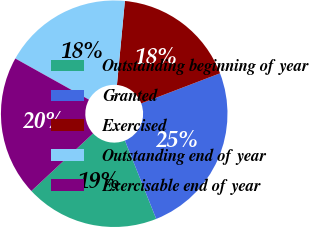Convert chart to OTSL. <chart><loc_0><loc_0><loc_500><loc_500><pie_chart><fcel>Outstanding beginning of year<fcel>Granted<fcel>Exercised<fcel>Outstanding end of year<fcel>Exercisable end of year<nl><fcel>19.1%<fcel>24.76%<fcel>17.69%<fcel>18.4%<fcel>20.05%<nl></chart> 